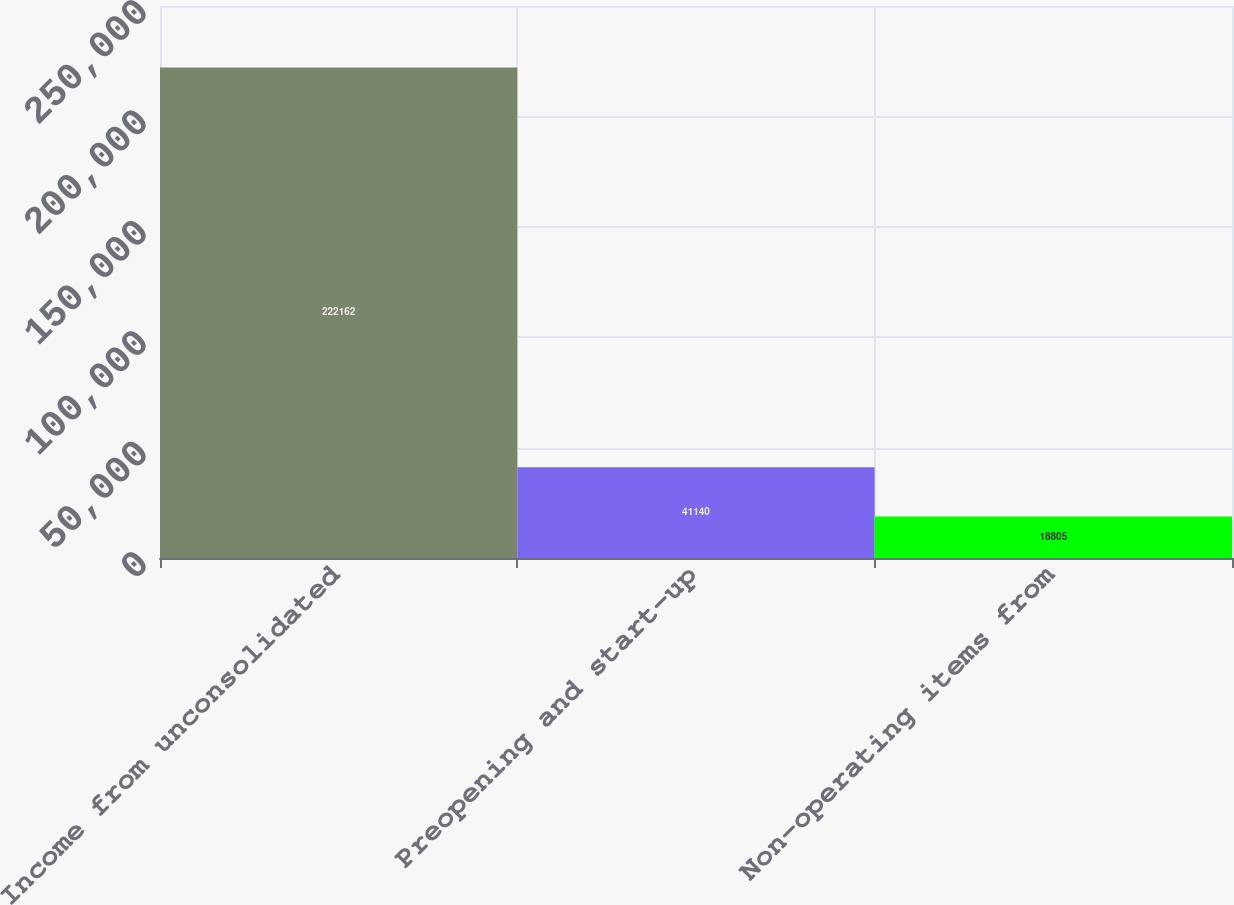<chart> <loc_0><loc_0><loc_500><loc_500><bar_chart><fcel>Income from unconsolidated<fcel>Preopening and start-up<fcel>Non-operating items from<nl><fcel>222162<fcel>41140<fcel>18805<nl></chart> 